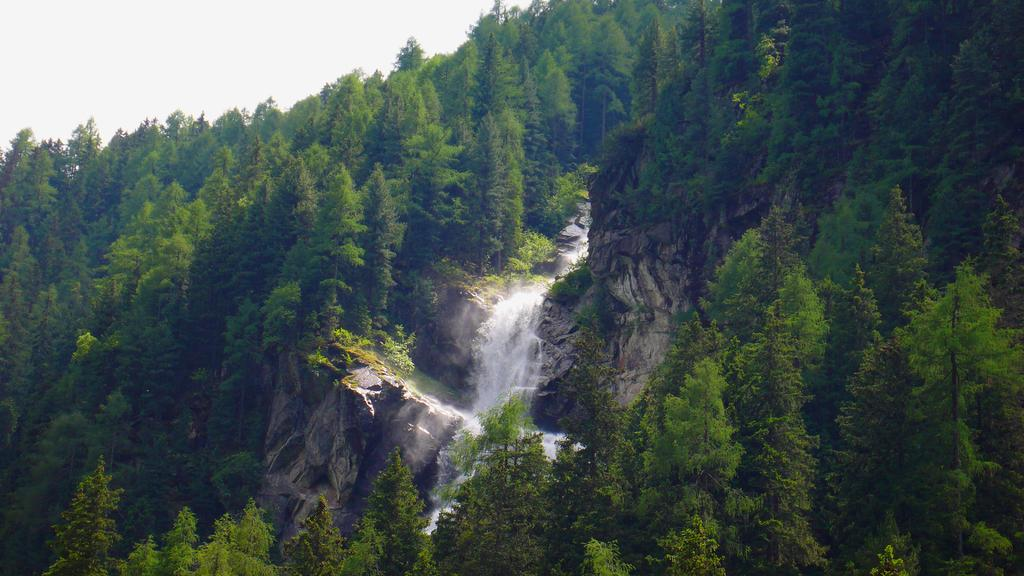What type of vegetation can be seen in the image? There are trees in the image. What is happening with the water in the image? Water is flowing in the image. What is the condition of the sky in the image? The sky is cloudy in the image. What type of fruit is hanging from the trees in the image? There is no fruit mentioned or visible in the image; it only features trees and flowing water. What treatment is being administered to the clouds in the image? There is no treatment being administered to the clouds in the image; the clouds are simply present in the sky. 